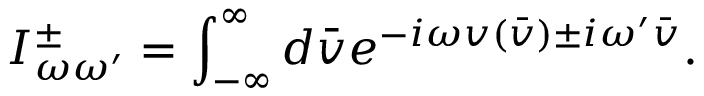Convert formula to latex. <formula><loc_0><loc_0><loc_500><loc_500>I _ { \omega \omega ^ { \prime } } ^ { \pm } = \int _ { - \infty } ^ { \infty } d \bar { v } e ^ { - i \omega v ( \bar { v } ) \pm i \omega ^ { \prime } \bar { v } } .</formula> 